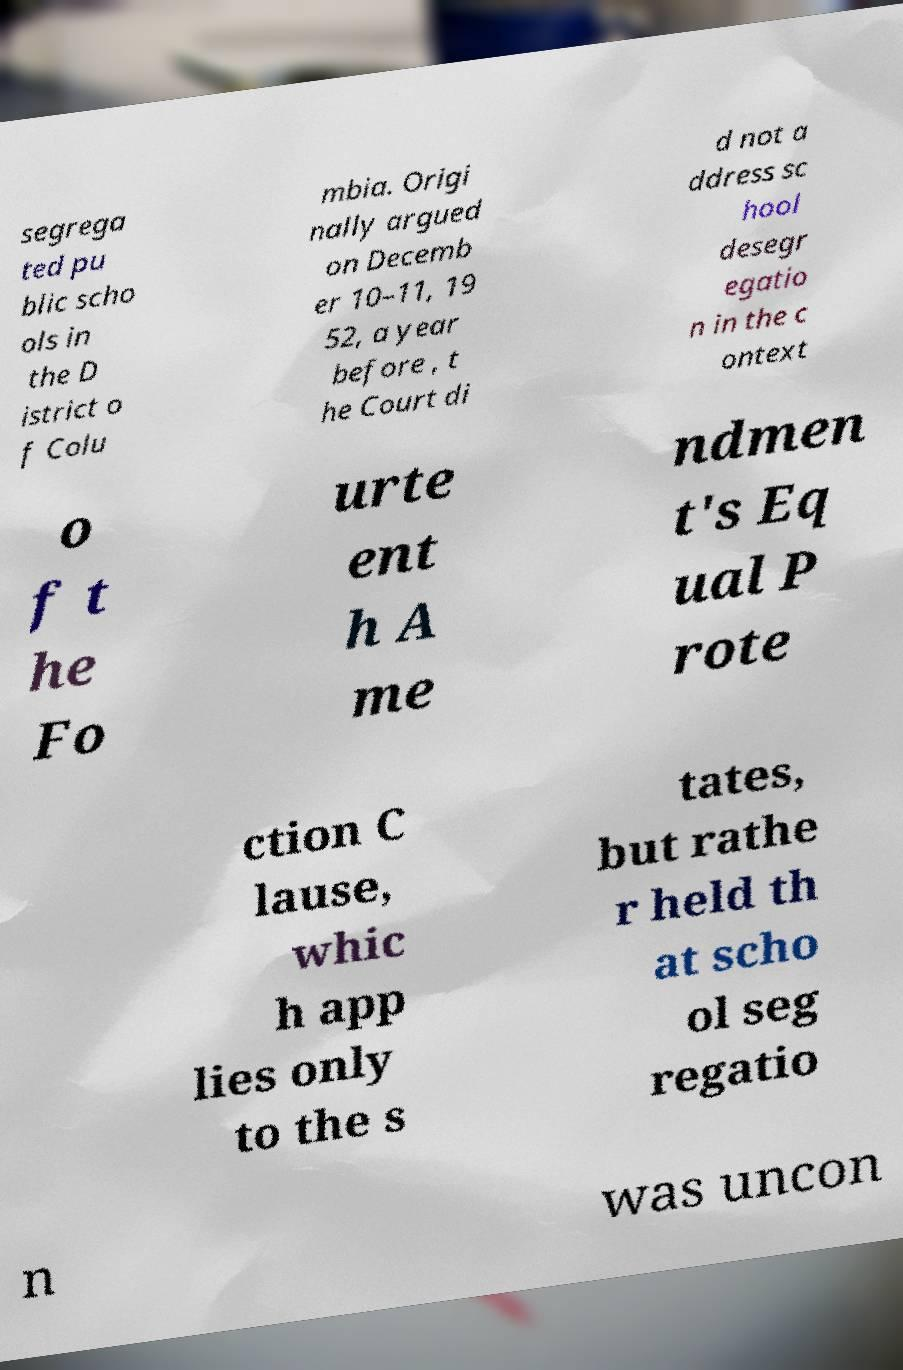Could you assist in decoding the text presented in this image and type it out clearly? segrega ted pu blic scho ols in the D istrict o f Colu mbia. Origi nally argued on Decemb er 10–11, 19 52, a year before , t he Court di d not a ddress sc hool desegr egatio n in the c ontext o f t he Fo urte ent h A me ndmen t's Eq ual P rote ction C lause, whic h app lies only to the s tates, but rathe r held th at scho ol seg regatio n was uncon 